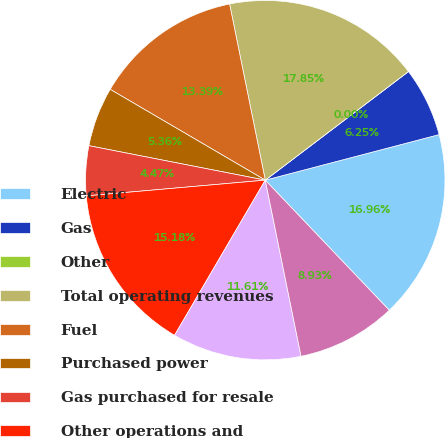<chart> <loc_0><loc_0><loc_500><loc_500><pie_chart><fcel>Electric<fcel>Gas<fcel>Other<fcel>Total operating revenues<fcel>Fuel<fcel>Purchased power<fcel>Gas purchased for resale<fcel>Other operations and<fcel>Depreciation and amortization<fcel>Taxes other than income taxes<nl><fcel>16.96%<fcel>6.25%<fcel>0.0%<fcel>17.85%<fcel>13.39%<fcel>5.36%<fcel>4.47%<fcel>15.18%<fcel>11.61%<fcel>8.93%<nl></chart> 